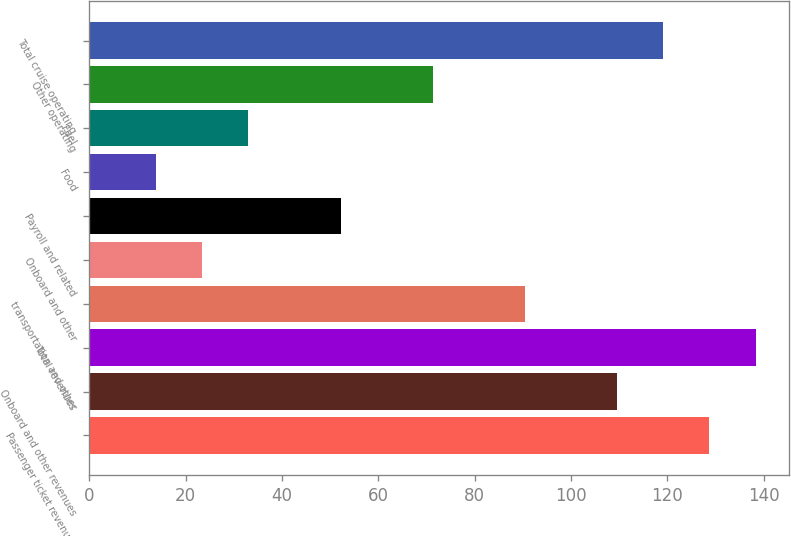<chart> <loc_0><loc_0><loc_500><loc_500><bar_chart><fcel>Passenger ticket revenues<fcel>Onboard and other revenues<fcel>Total revenues<fcel>transportation and other<fcel>Onboard and other<fcel>Payroll and related<fcel>Food<fcel>Fuel<fcel>Other operating<fcel>Total cruise operating<nl><fcel>128.71<fcel>109.57<fcel>138.28<fcel>90.43<fcel>23.44<fcel>52.15<fcel>13.87<fcel>33.01<fcel>71.29<fcel>119.14<nl></chart> 